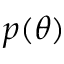Convert formula to latex. <formula><loc_0><loc_0><loc_500><loc_500>p ( { \theta } )</formula> 